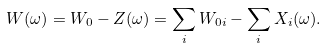Convert formula to latex. <formula><loc_0><loc_0><loc_500><loc_500>W ( \omega ) = W _ { 0 } - Z ( \omega ) = \sum _ { i } W _ { 0 i } - \sum _ { i } X _ { i } ( \omega ) .</formula> 